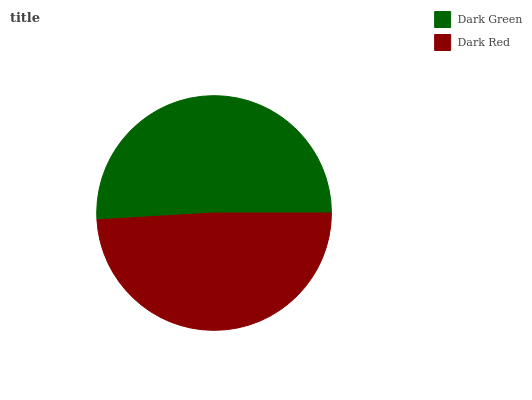Is Dark Red the minimum?
Answer yes or no. Yes. Is Dark Green the maximum?
Answer yes or no. Yes. Is Dark Red the maximum?
Answer yes or no. No. Is Dark Green greater than Dark Red?
Answer yes or no. Yes. Is Dark Red less than Dark Green?
Answer yes or no. Yes. Is Dark Red greater than Dark Green?
Answer yes or no. No. Is Dark Green less than Dark Red?
Answer yes or no. No. Is Dark Green the high median?
Answer yes or no. Yes. Is Dark Red the low median?
Answer yes or no. Yes. Is Dark Red the high median?
Answer yes or no. No. Is Dark Green the low median?
Answer yes or no. No. 